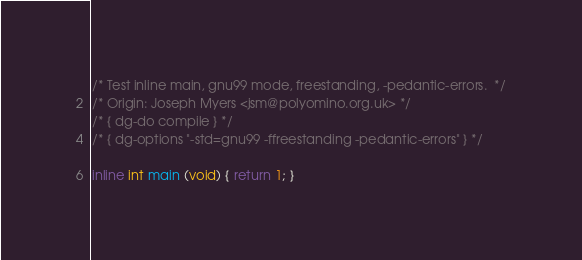Convert code to text. <code><loc_0><loc_0><loc_500><loc_500><_C_>/* Test inline main, gnu99 mode, freestanding, -pedantic-errors.  */
/* Origin: Joseph Myers <jsm@polyomino.org.uk> */
/* { dg-do compile } */
/* { dg-options "-std=gnu99 -ffreestanding -pedantic-errors" } */

inline int main (void) { return 1; }
</code> 